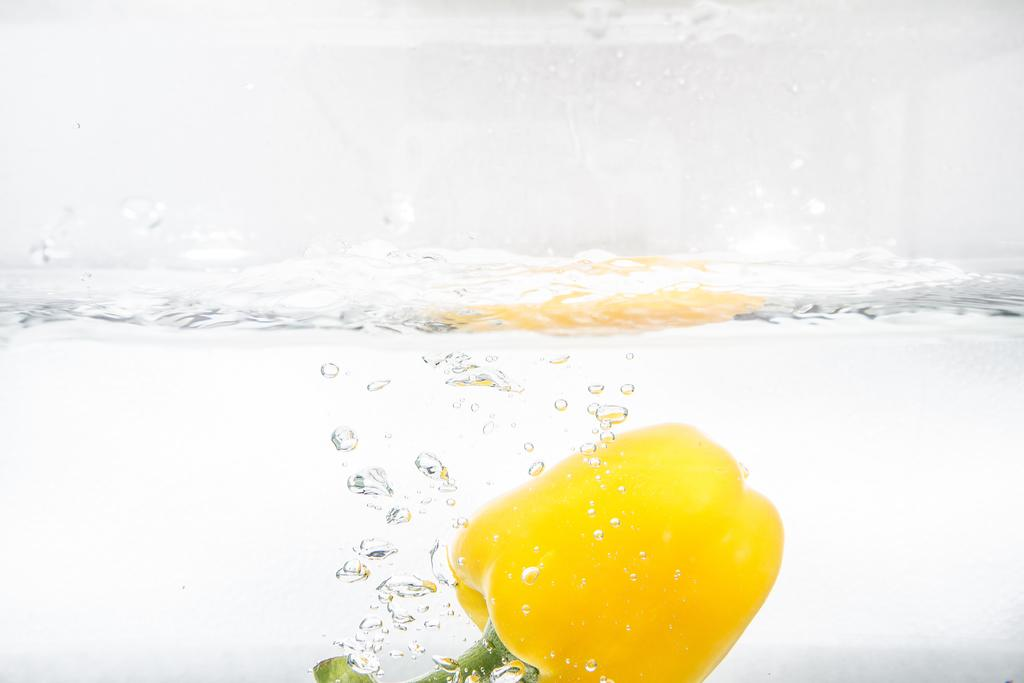What is the main object in the image? There is a capsicum in the image. How is the capsicum situated in the image? The capsicum is inside the water. What type of reaction does the capsicum have when it sees the wish in the image? There is no mention of a wish in the image, and the capsicum is an inanimate object, so it cannot have a reaction. 